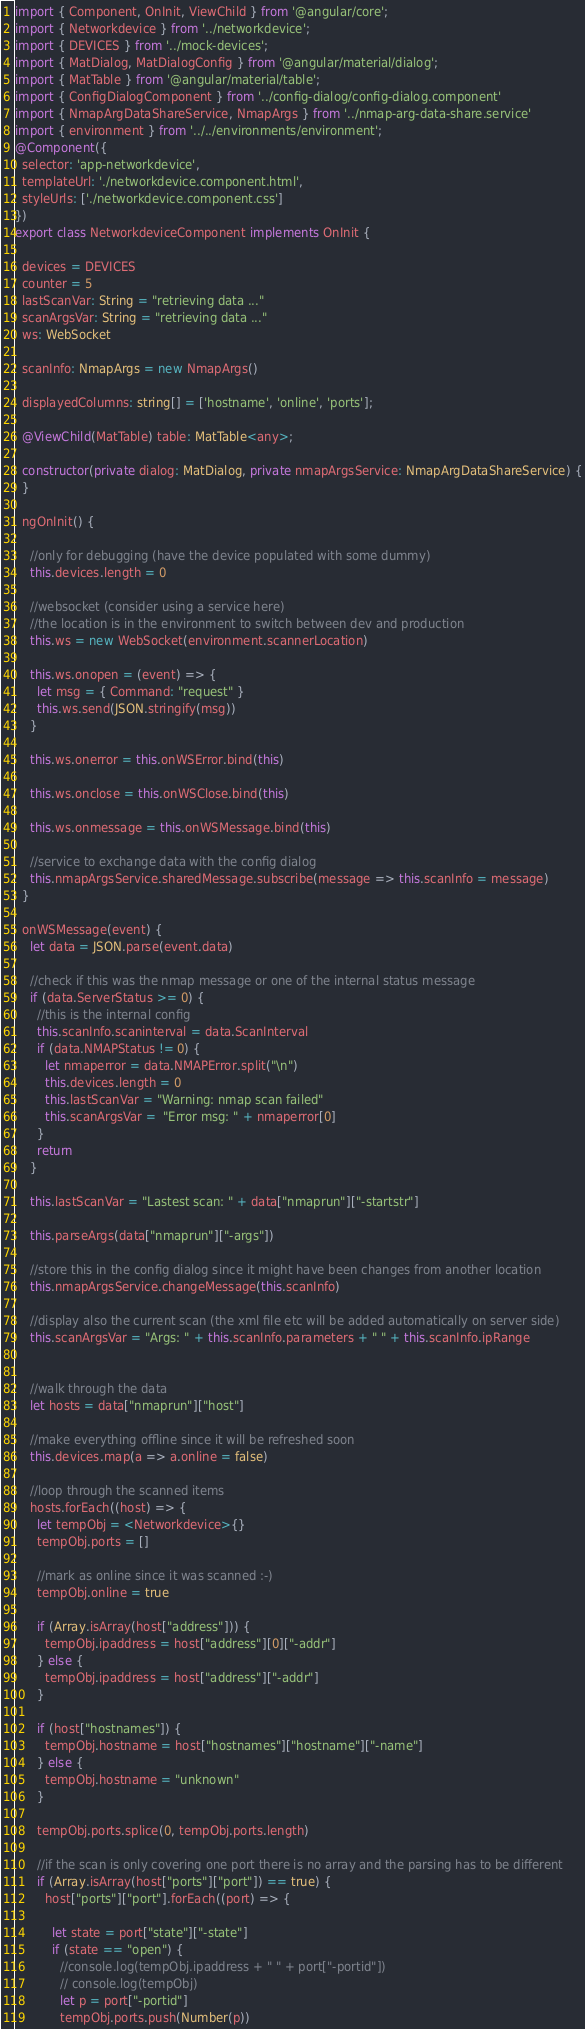Convert code to text. <code><loc_0><loc_0><loc_500><loc_500><_TypeScript_>import { Component, OnInit, ViewChild } from '@angular/core';
import { Networkdevice } from '../networkdevice';
import { DEVICES } from '../mock-devices';
import { MatDialog, MatDialogConfig } from '@angular/material/dialog';
import { MatTable } from '@angular/material/table';
import { ConfigDialogComponent } from '../config-dialog/config-dialog.component'
import { NmapArgDataShareService, NmapArgs } from '../nmap-arg-data-share.service'
import { environment } from '../../environments/environment';
@Component({
  selector: 'app-networkdevice',
  templateUrl: './networkdevice.component.html',
  styleUrls: ['./networkdevice.component.css']
})
export class NetworkdeviceComponent implements OnInit {

  devices = DEVICES
  counter = 5
  lastScanVar: String = "retrieving data ..."
  scanArgsVar: String = "retrieving data ..."
  ws: WebSocket

  scanInfo: NmapArgs = new NmapArgs()

  displayedColumns: string[] = ['hostname', 'online', 'ports'];

  @ViewChild(MatTable) table: MatTable<any>;

  constructor(private dialog: MatDialog, private nmapArgsService: NmapArgDataShareService) {
  }

  ngOnInit() {

    //only for debugging (have the device populated with some dummy)
    this.devices.length = 0

    //websocket (consider using a service here)
    //the location is in the environment to switch between dev and production
    this.ws = new WebSocket(environment.scannerLocation)

    this.ws.onopen = (event) => {
      let msg = { Command: "request" }
      this.ws.send(JSON.stringify(msg))
    }

    this.ws.onerror = this.onWSError.bind(this)

    this.ws.onclose = this.onWSClose.bind(this)

    this.ws.onmessage = this.onWSMessage.bind(this)

    //service to exchange data with the config dialog
    this.nmapArgsService.sharedMessage.subscribe(message => this.scanInfo = message)
  }

  onWSMessage(event) {
    let data = JSON.parse(event.data)

    //check if this was the nmap message or one of the internal status message
    if (data.ServerStatus >= 0) {
      //this is the internal config
      this.scanInfo.scaninterval = data.ScanInterval
      if (data.NMAPStatus != 0) {
        let nmaperror = data.NMAPError.split("\n")
        this.devices.length = 0
        this.lastScanVar = "Warning: nmap scan failed"
        this.scanArgsVar =  "Error msg: " + nmaperror[0]
      }
      return
    }

    this.lastScanVar = "Lastest scan: " + data["nmaprun"]["-startstr"]

    this.parseArgs(data["nmaprun"]["-args"])

    //store this in the config dialog since it might have been changes from another location
    this.nmapArgsService.changeMessage(this.scanInfo)

    //display also the current scan (the xml file etc will be added automatically on server side)
    this.scanArgsVar = "Args: " + this.scanInfo.parameters + " " + this.scanInfo.ipRange


    //walk through the data
    let hosts = data["nmaprun"]["host"]

    //make everything offline since it will be refreshed soon
    this.devices.map(a => a.online = false)

    //loop through the scanned items
    hosts.forEach((host) => {
      let tempObj = <Networkdevice>{}
      tempObj.ports = []

      //mark as online since it was scanned :-)
      tempObj.online = true

      if (Array.isArray(host["address"])) {
        tempObj.ipaddress = host["address"][0]["-addr"]
      } else {
        tempObj.ipaddress = host["address"]["-addr"]
      }

      if (host["hostnames"]) {
        tempObj.hostname = host["hostnames"]["hostname"]["-name"]
      } else {
        tempObj.hostname = "unknown"
      }

      tempObj.ports.splice(0, tempObj.ports.length)

      //if the scan is only covering one port there is no array and the parsing has to be different
      if (Array.isArray(host["ports"]["port"]) == true) {
        host["ports"]["port"].forEach((port) => {

          let state = port["state"]["-state"]
          if (state == "open") {
            //console.log(tempObj.ipaddress + " " + port["-portid"])
            // console.log(tempObj)
            let p = port["-portid"]
            tempObj.ports.push(Number(p))</code> 